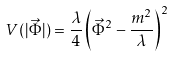<formula> <loc_0><loc_0><loc_500><loc_500>V ( | \vec { \Phi } | ) = \frac { \lambda } { 4 } \left ( \vec { \Phi } ^ { 2 } - \frac { m ^ { 2 } } { \lambda } \right ) ^ { 2 }</formula> 